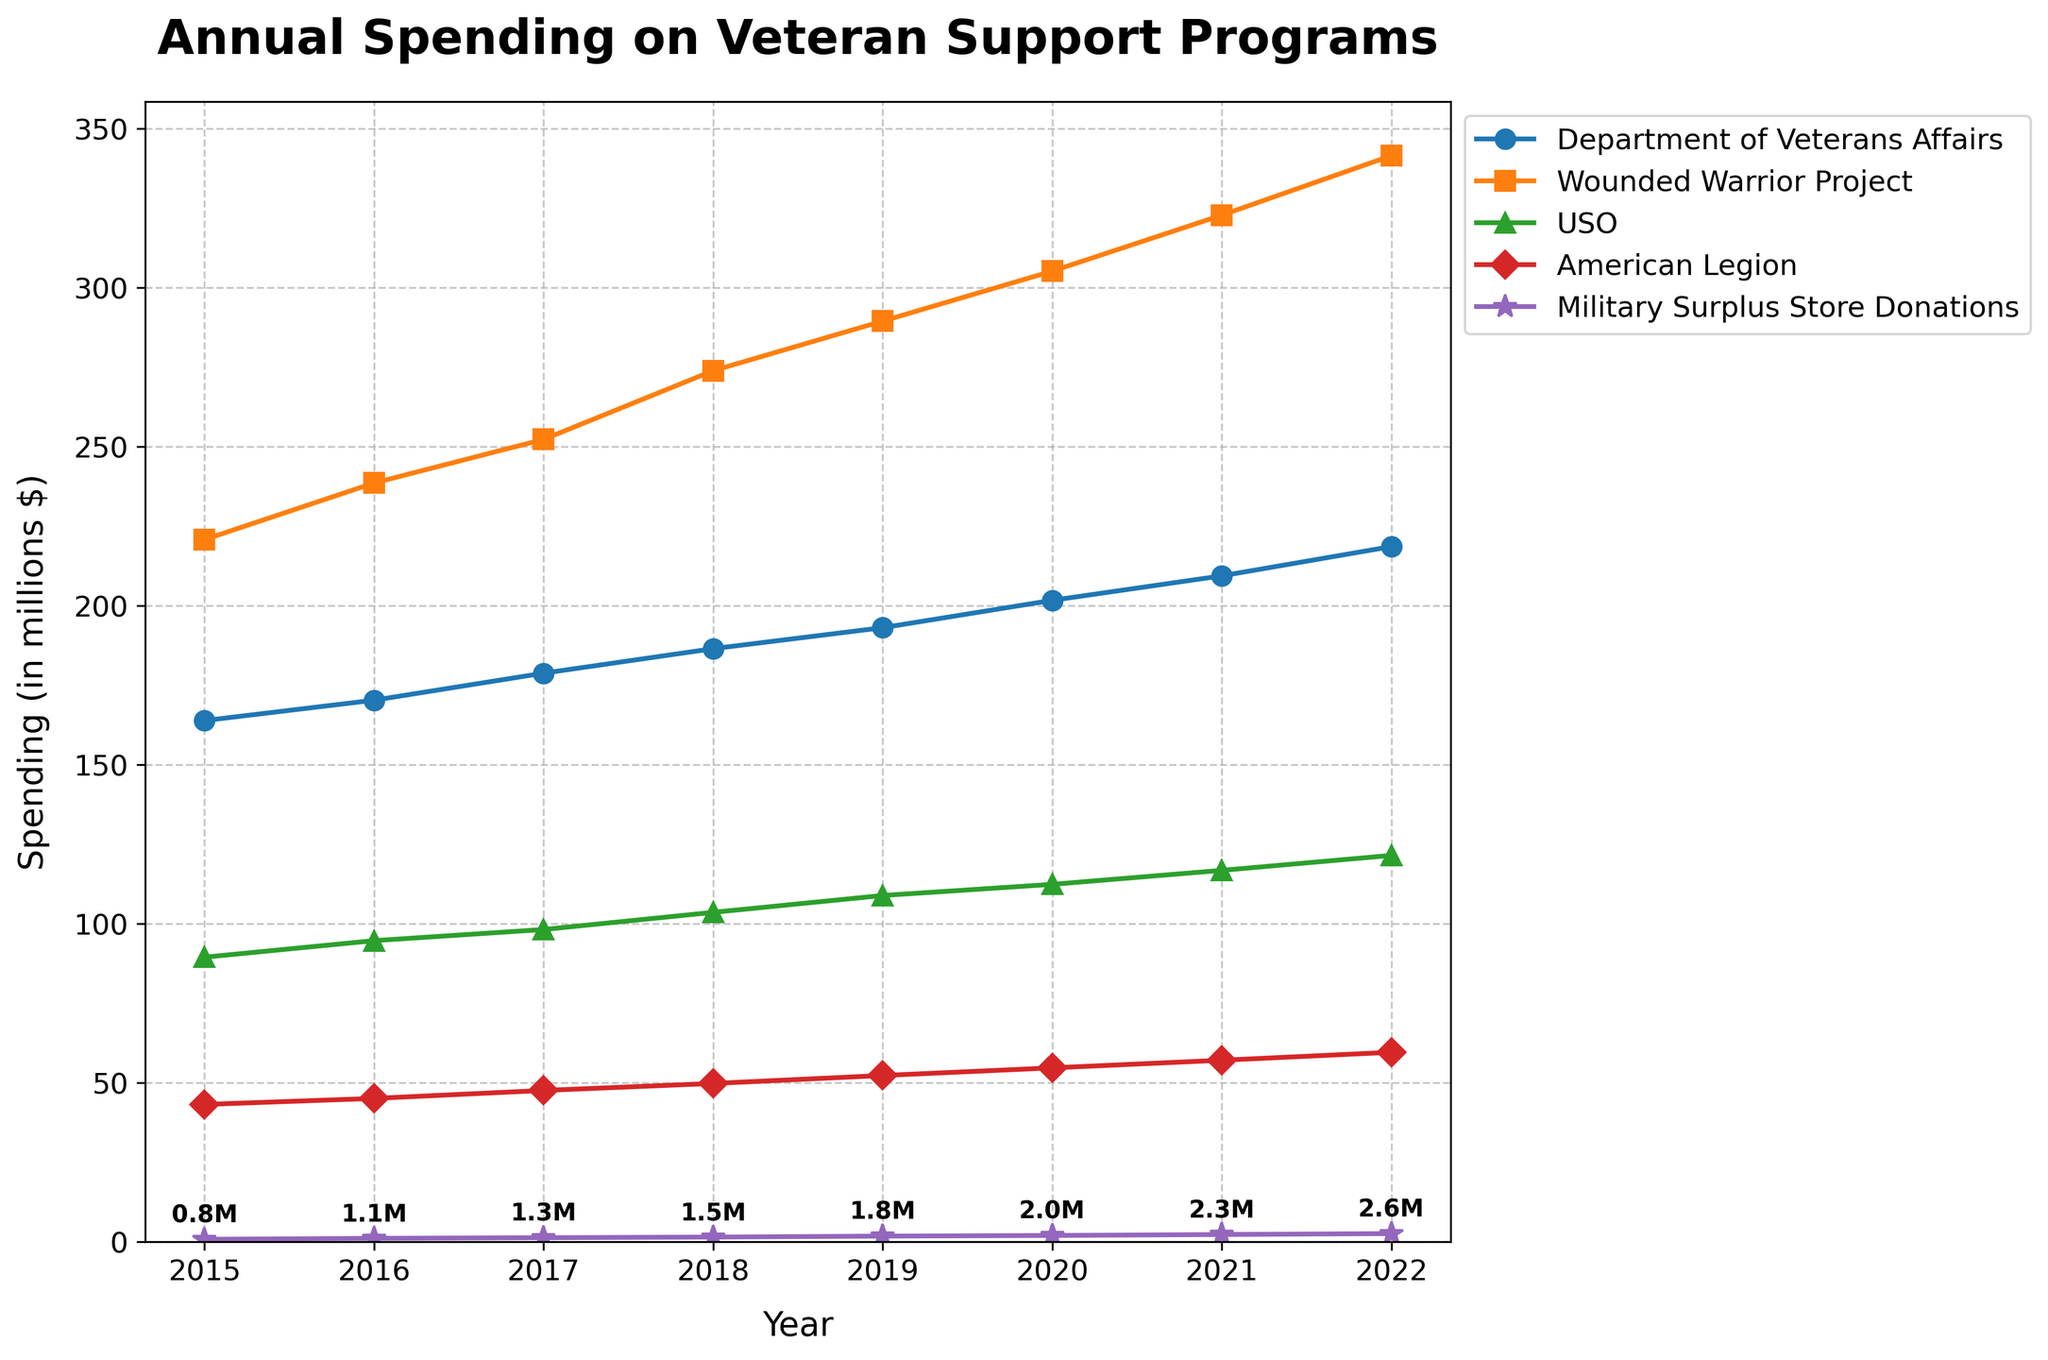What is the total spending by the Wounded Warrior Project and the USO in 2022? First, locate the 2022 data points for the Wounded Warrior Project and the USO. The Wounded Warrior Project has a spending of $341.5 million, and the USO has $121.5 million. Summing these values gives $341.5 million + $121.5 million = $463 million.
Answer: $463 million What is the difference in spending between the Department of Veterans Affairs and the American Legion in 2020? Identify the 2020 data points for the Department of Veterans Affairs and the American Legion. The Department of Veterans Affairs has $201.7 million, and the American Legion has $54.7 million. Subtract the American Legion's value from the Department of Veterans Affairs' value: $201.7 million - $54.7 million = $147 million.
Answer: $147 million Which organization had the highest increase in spending from 2019 to 2020? Check the 2019 and 2020 data points for each organization and calculate the differences: Department of Veterans Affairs ($201.7 million - $193.1 million = $8.6 million), Wounded Warrior Project ($305.2 million - $289.5 million = $15.7 million), USO ($112.4 million - $108.9 million = $3.5 million), American Legion ($54.7 million - $52.3 million = $2.4 million), and Military Surplus Store Donations ($2 million - $1.8 million = $0.2 million). The Wounded Warrior Project had the highest increase.
Answer: Wounded Warrior Project Which organization had the lowest spending in 2015? Locate the 2015 data points for each organization. The values are: Department of Veterans Affairs ($163.9 million), Wounded Warrior Project ($220.8 million), USO ($89.5 million), American Legion ($43.2 million), and Military Surplus Store Donations ($0.8 million). The Military Surplus Store Donations had the lowest spending.
Answer: Military Surplus Store Donations Is the spending trend of the Military Surplus Store Donations increasing every year from 2015 to 2022? Check the yearly data points for the Military Surplus Store Donations: 2015 ($0.8 million), 2016 ($1.1 million), 2017 ($1.3 million), 2018 ($1.5 million), 2019 ($1.8 million), 2020 ($2 million), 2021 ($2.3 million), and 2022 ($2.6 million). The values increase every year.
Answer: Yes How much more did the USO spend in 2022 compared to 2015? Look at the USO's spending in 2015 ($89.5 million) and 2022 ($121.5 million). Calculate the difference: $121.5 million - $89.5 million = $32 million.
Answer: $32 million Which organization shows the smallest change in spending between any two consecutive years, and what is this change? Compare the yearly changes for each organization. For instance, the Department of Veterans Affairs changes by $6.4 million from 2015 to 2016, by $8.5 million from 2016 to 2017, etc. Find the minimum change across all organizations: the smallest change is the American Legion from 2015 to 2016 ($45.1 million - $43.2 million = $1.9 million).
Answer: American Legion, $1.9 million In which year did the Wounded Warrior Project first surpass $300 million in spending? Review the yearly data for the Wounded Warrior Project. The first value over $300 million is in 2020 ($305.2 million).
Answer: 2020 